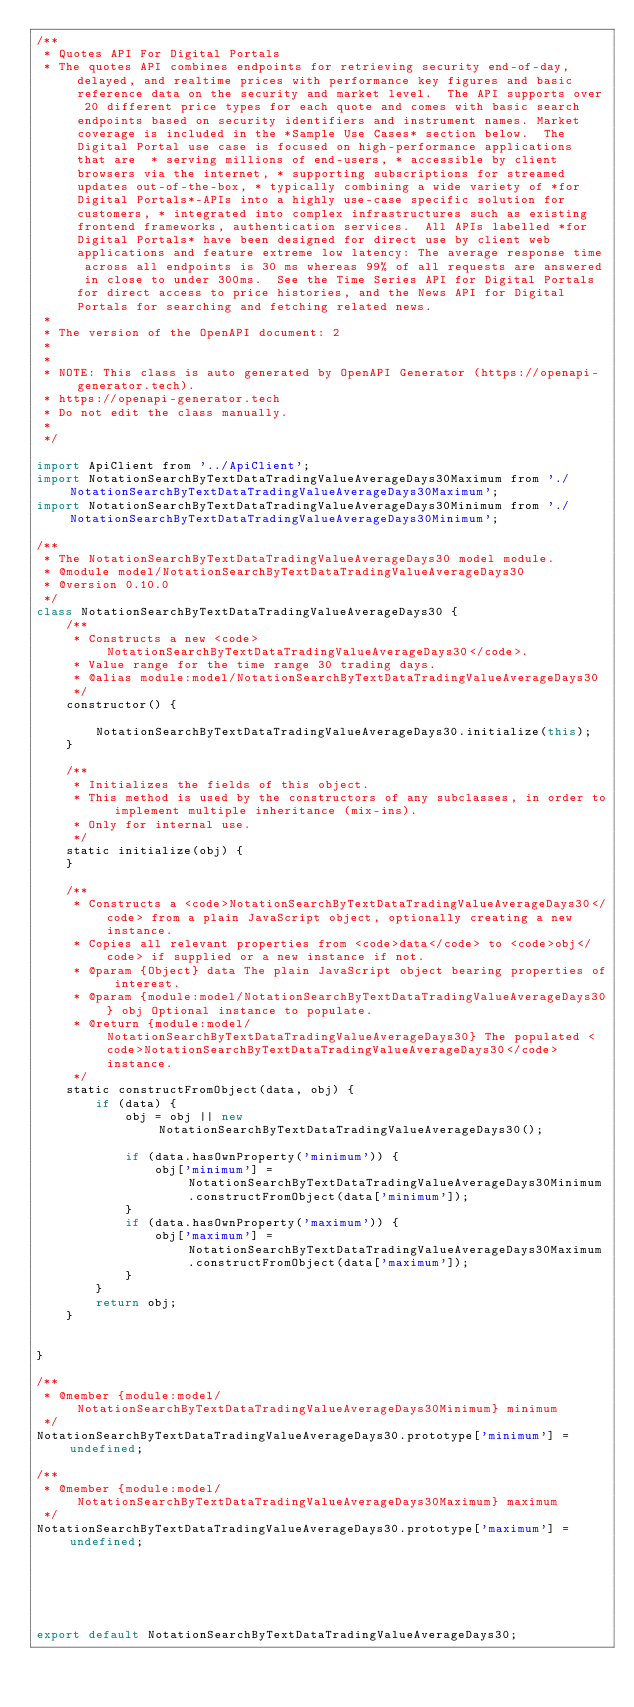Convert code to text. <code><loc_0><loc_0><loc_500><loc_500><_JavaScript_>/**
 * Quotes API For Digital Portals
 * The quotes API combines endpoints for retrieving security end-of-day, delayed, and realtime prices with performance key figures and basic reference data on the security and market level.  The API supports over 20 different price types for each quote and comes with basic search endpoints based on security identifiers and instrument names. Market coverage is included in the *Sample Use Cases* section below.  The Digital Portal use case is focused on high-performance applications that are  * serving millions of end-users, * accessible by client browsers via the internet, * supporting subscriptions for streamed updates out-of-the-box, * typically combining a wide variety of *for Digital Portals*-APIs into a highly use-case specific solution for customers, * integrated into complex infrastructures such as existing frontend frameworks, authentication services.  All APIs labelled *for Digital Portals* have been designed for direct use by client web applications and feature extreme low latency: The average response time across all endpoints is 30 ms whereas 99% of all requests are answered in close to under 300ms.  See the Time Series API for Digital Portals for direct access to price histories, and the News API for Digital Portals for searching and fetching related news.
 *
 * The version of the OpenAPI document: 2
 * 
 *
 * NOTE: This class is auto generated by OpenAPI Generator (https://openapi-generator.tech).
 * https://openapi-generator.tech
 * Do not edit the class manually.
 *
 */

import ApiClient from '../ApiClient';
import NotationSearchByTextDataTradingValueAverageDays30Maximum from './NotationSearchByTextDataTradingValueAverageDays30Maximum';
import NotationSearchByTextDataTradingValueAverageDays30Minimum from './NotationSearchByTextDataTradingValueAverageDays30Minimum';

/**
 * The NotationSearchByTextDataTradingValueAverageDays30 model module.
 * @module model/NotationSearchByTextDataTradingValueAverageDays30
 * @version 0.10.0
 */
class NotationSearchByTextDataTradingValueAverageDays30 {
    /**
     * Constructs a new <code>NotationSearchByTextDataTradingValueAverageDays30</code>.
     * Value range for the time range 30 trading days.
     * @alias module:model/NotationSearchByTextDataTradingValueAverageDays30
     */
    constructor() { 
        
        NotationSearchByTextDataTradingValueAverageDays30.initialize(this);
    }

    /**
     * Initializes the fields of this object.
     * This method is used by the constructors of any subclasses, in order to implement multiple inheritance (mix-ins).
     * Only for internal use.
     */
    static initialize(obj) { 
    }

    /**
     * Constructs a <code>NotationSearchByTextDataTradingValueAverageDays30</code> from a plain JavaScript object, optionally creating a new instance.
     * Copies all relevant properties from <code>data</code> to <code>obj</code> if supplied or a new instance if not.
     * @param {Object} data The plain JavaScript object bearing properties of interest.
     * @param {module:model/NotationSearchByTextDataTradingValueAverageDays30} obj Optional instance to populate.
     * @return {module:model/NotationSearchByTextDataTradingValueAverageDays30} The populated <code>NotationSearchByTextDataTradingValueAverageDays30</code> instance.
     */
    static constructFromObject(data, obj) {
        if (data) {
            obj = obj || new NotationSearchByTextDataTradingValueAverageDays30();

            if (data.hasOwnProperty('minimum')) {
                obj['minimum'] = NotationSearchByTextDataTradingValueAverageDays30Minimum.constructFromObject(data['minimum']);
            }
            if (data.hasOwnProperty('maximum')) {
                obj['maximum'] = NotationSearchByTextDataTradingValueAverageDays30Maximum.constructFromObject(data['maximum']);
            }
        }
        return obj;
    }


}

/**
 * @member {module:model/NotationSearchByTextDataTradingValueAverageDays30Minimum} minimum
 */
NotationSearchByTextDataTradingValueAverageDays30.prototype['minimum'] = undefined;

/**
 * @member {module:model/NotationSearchByTextDataTradingValueAverageDays30Maximum} maximum
 */
NotationSearchByTextDataTradingValueAverageDays30.prototype['maximum'] = undefined;






export default NotationSearchByTextDataTradingValueAverageDays30;

</code> 